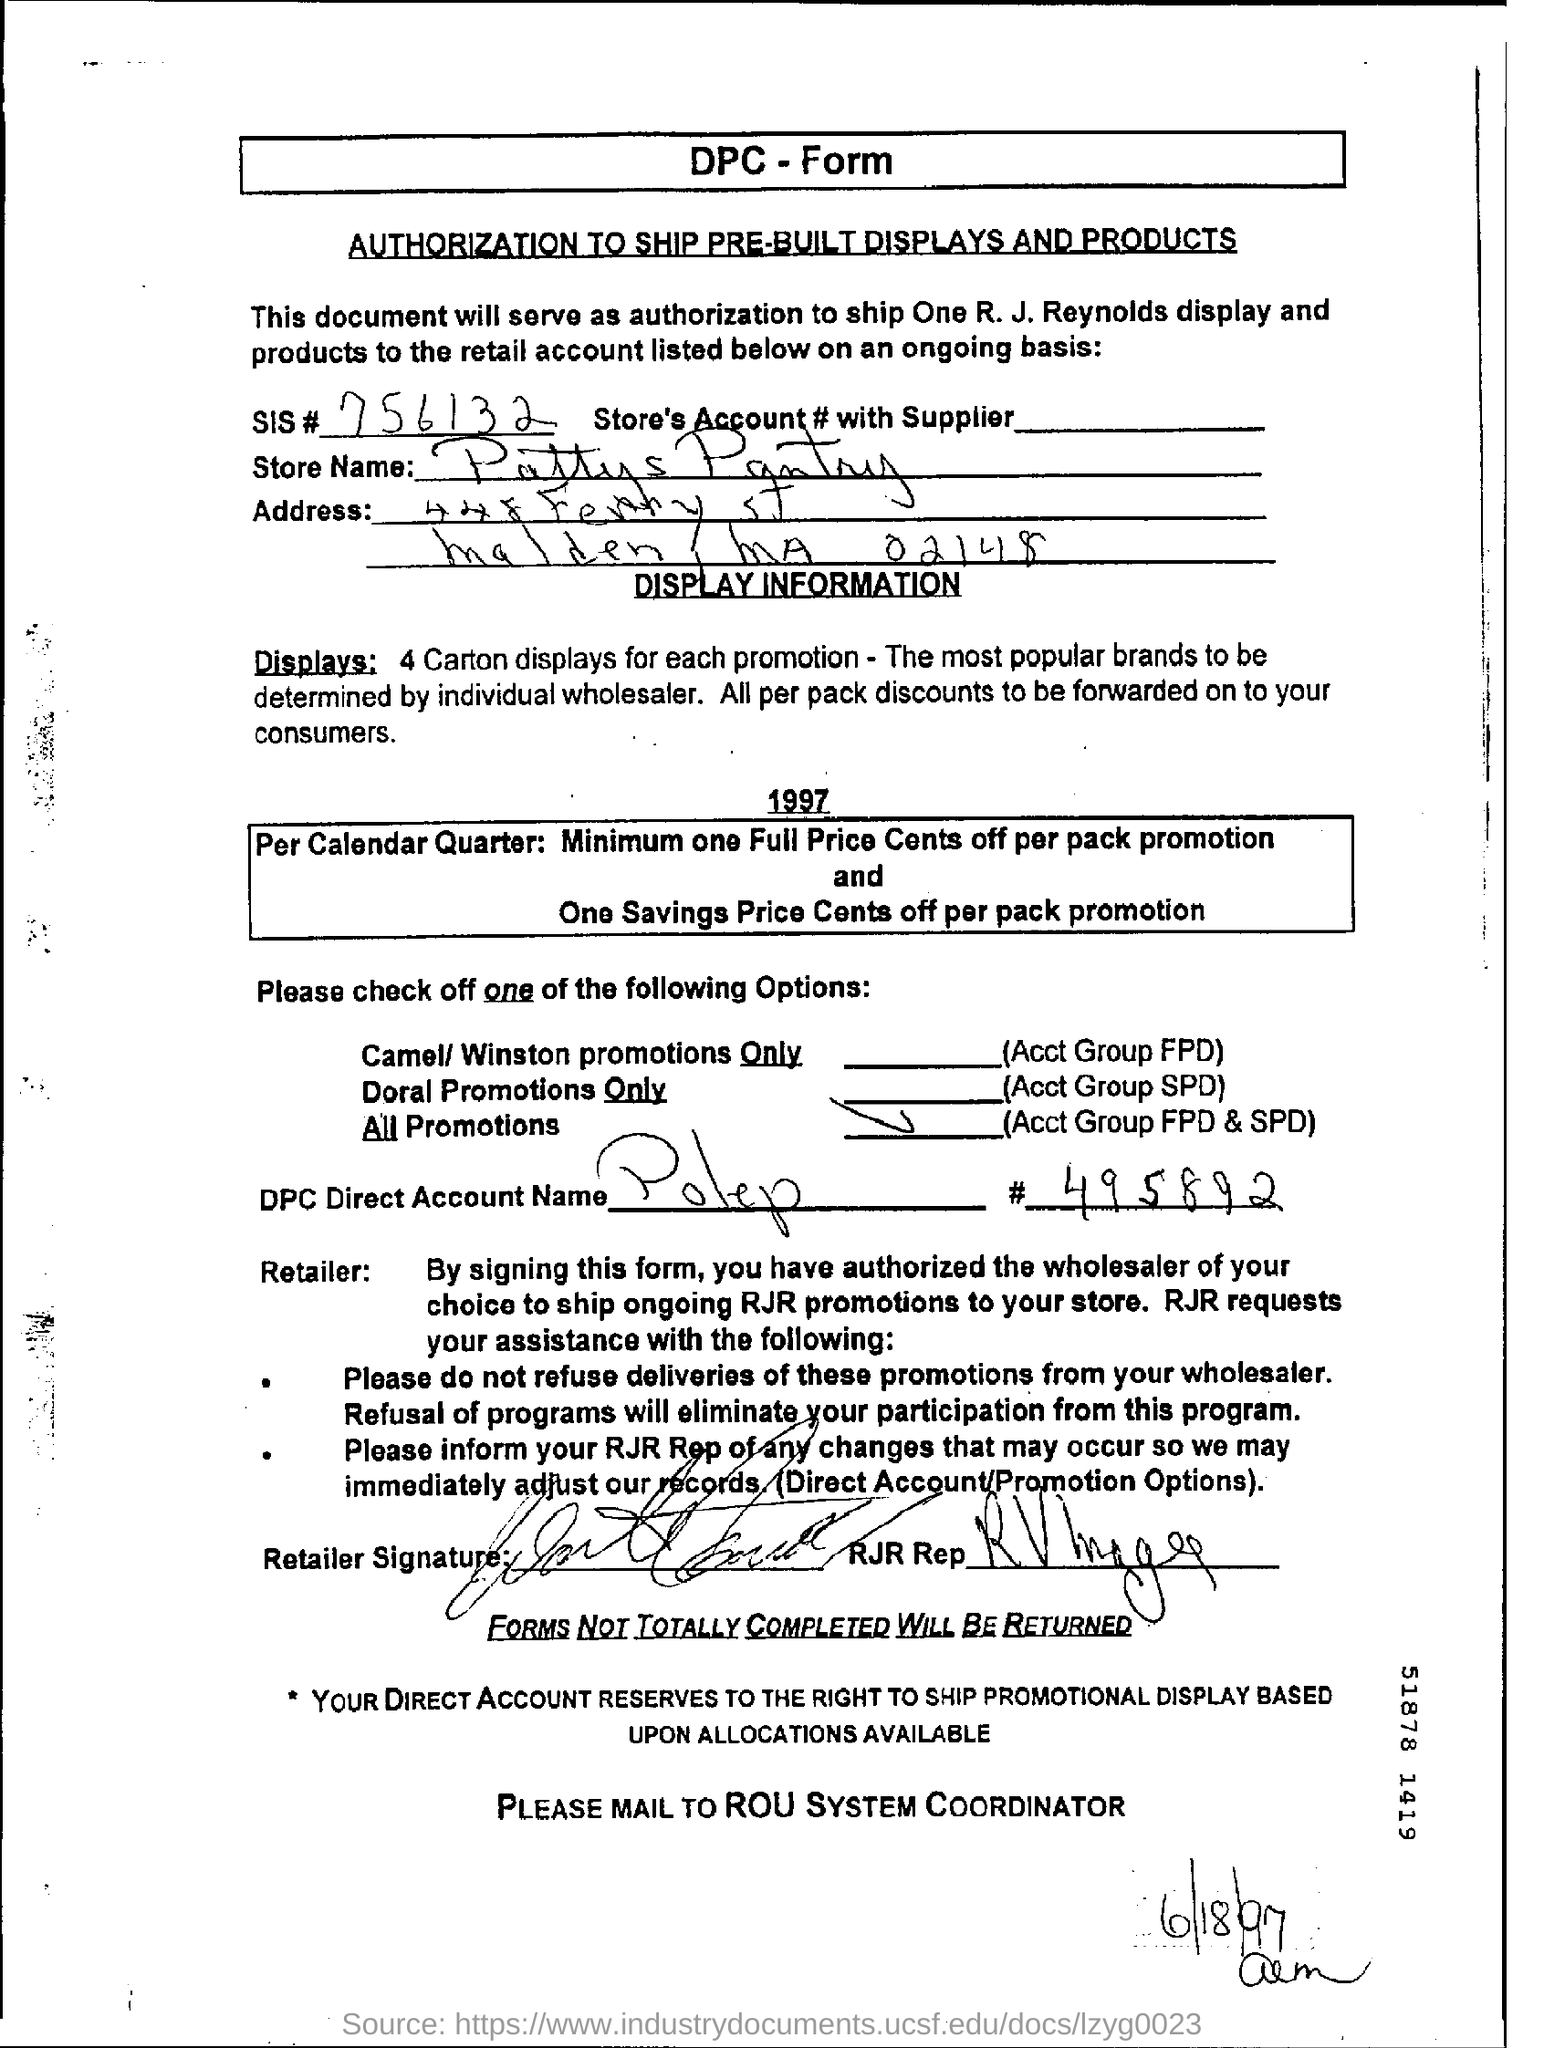What is the store name given in the form?
Make the answer very short. Pattys Pantry. What is SIS# given in the form?
Your answer should be very brief. 756132. What is the date mentioned in this form?
Ensure brevity in your answer.  6/18/97. 